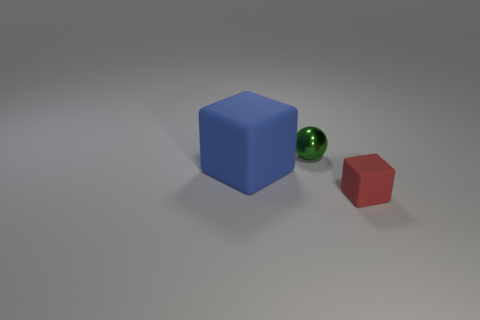There is a big object that is the same material as the tiny red cube; what shape is it?
Provide a succinct answer. Cube. Does the ball have the same material as the small thing right of the small green object?
Keep it short and to the point. No. Is the shape of the tiny thing that is in front of the small green sphere the same as  the large matte thing?
Provide a short and direct response. Yes. What is the material of the large object that is the same shape as the tiny rubber object?
Ensure brevity in your answer.  Rubber. Is the shape of the small green metal object the same as the thing that is in front of the big cube?
Give a very brief answer. No. The object that is on the right side of the large block and left of the small matte block is what color?
Offer a terse response. Green. Are any gray rubber cylinders visible?
Offer a terse response. No. Is the number of objects on the right side of the blue matte object the same as the number of big rubber cubes?
Your response must be concise. No. How many other objects are there of the same shape as the metal object?
Your response must be concise. 0. There is a tiny rubber thing; what shape is it?
Offer a terse response. Cube. 